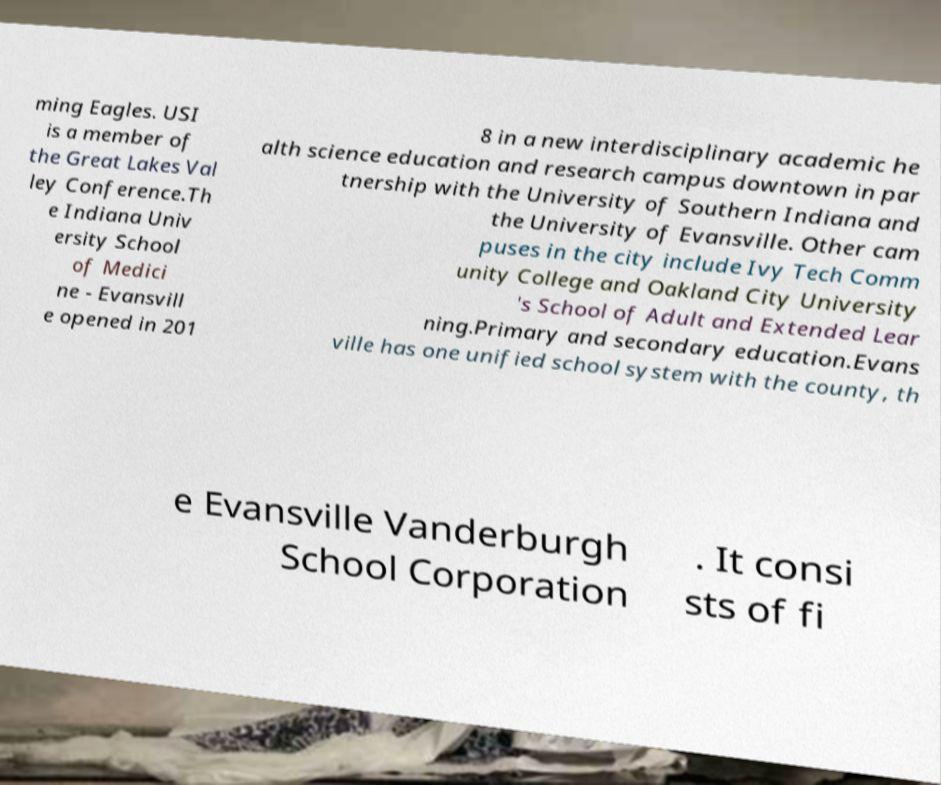For documentation purposes, I need the text within this image transcribed. Could you provide that? ming Eagles. USI is a member of the Great Lakes Val ley Conference.Th e Indiana Univ ersity School of Medici ne - Evansvill e opened in 201 8 in a new interdisciplinary academic he alth science education and research campus downtown in par tnership with the University of Southern Indiana and the University of Evansville. Other cam puses in the city include Ivy Tech Comm unity College and Oakland City University 's School of Adult and Extended Lear ning.Primary and secondary education.Evans ville has one unified school system with the county, th e Evansville Vanderburgh School Corporation . It consi sts of fi 